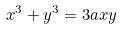Convert formula to latex. <formula><loc_0><loc_0><loc_500><loc_500>x ^ { 3 } + y ^ { 3 } = 3 a x y</formula> 